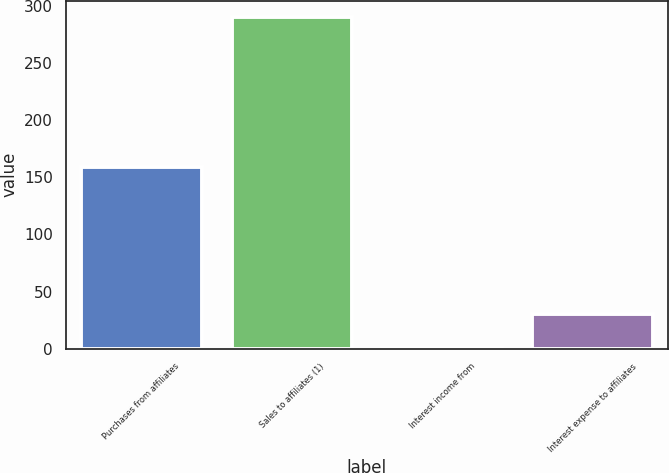<chart> <loc_0><loc_0><loc_500><loc_500><bar_chart><fcel>Purchases from affiliates<fcel>Sales to affiliates (1)<fcel>Interest income from<fcel>Interest expense to affiliates<nl><fcel>159<fcel>290<fcel>1<fcel>29.9<nl></chart> 